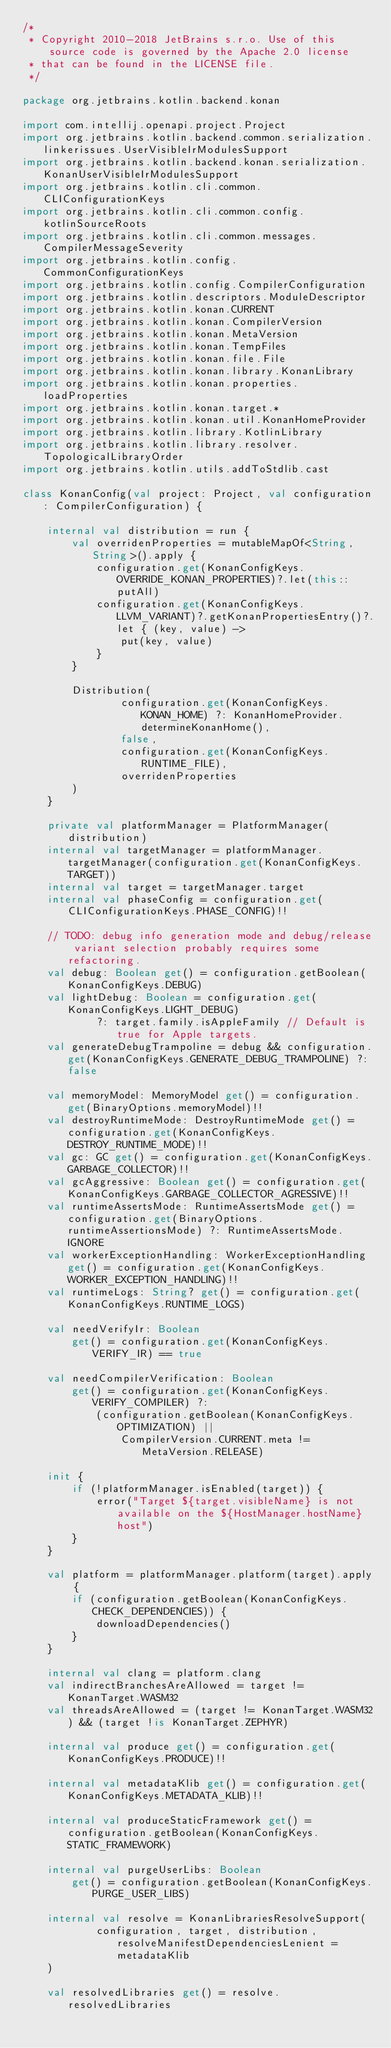Convert code to text. <code><loc_0><loc_0><loc_500><loc_500><_Kotlin_>/*
 * Copyright 2010-2018 JetBrains s.r.o. Use of this source code is governed by the Apache 2.0 license
 * that can be found in the LICENSE file.
 */

package org.jetbrains.kotlin.backend.konan

import com.intellij.openapi.project.Project
import org.jetbrains.kotlin.backend.common.serialization.linkerissues.UserVisibleIrModulesSupport
import org.jetbrains.kotlin.backend.konan.serialization.KonanUserVisibleIrModulesSupport
import org.jetbrains.kotlin.cli.common.CLIConfigurationKeys
import org.jetbrains.kotlin.cli.common.config.kotlinSourceRoots
import org.jetbrains.kotlin.cli.common.messages.CompilerMessageSeverity
import org.jetbrains.kotlin.config.CommonConfigurationKeys
import org.jetbrains.kotlin.config.CompilerConfiguration
import org.jetbrains.kotlin.descriptors.ModuleDescriptor
import org.jetbrains.kotlin.konan.CURRENT
import org.jetbrains.kotlin.konan.CompilerVersion
import org.jetbrains.kotlin.konan.MetaVersion
import org.jetbrains.kotlin.konan.TempFiles
import org.jetbrains.kotlin.konan.file.File
import org.jetbrains.kotlin.konan.library.KonanLibrary
import org.jetbrains.kotlin.konan.properties.loadProperties
import org.jetbrains.kotlin.konan.target.*
import org.jetbrains.kotlin.konan.util.KonanHomeProvider
import org.jetbrains.kotlin.library.KotlinLibrary
import org.jetbrains.kotlin.library.resolver.TopologicalLibraryOrder
import org.jetbrains.kotlin.utils.addToStdlib.cast

class KonanConfig(val project: Project, val configuration: CompilerConfiguration) {

    internal val distribution = run {
        val overridenProperties = mutableMapOf<String, String>().apply {
            configuration.get(KonanConfigKeys.OVERRIDE_KONAN_PROPERTIES)?.let(this::putAll)
            configuration.get(KonanConfigKeys.LLVM_VARIANT)?.getKonanPropertiesEntry()?.let { (key, value) ->
                put(key, value)
            }
        }

        Distribution(
                configuration.get(KonanConfigKeys.KONAN_HOME) ?: KonanHomeProvider.determineKonanHome(),
                false,
                configuration.get(KonanConfigKeys.RUNTIME_FILE),
                overridenProperties
        )
    }

    private val platformManager = PlatformManager(distribution)
    internal val targetManager = platformManager.targetManager(configuration.get(KonanConfigKeys.TARGET))
    internal val target = targetManager.target
    internal val phaseConfig = configuration.get(CLIConfigurationKeys.PHASE_CONFIG)!!

    // TODO: debug info generation mode and debug/release variant selection probably requires some refactoring.
    val debug: Boolean get() = configuration.getBoolean(KonanConfigKeys.DEBUG)
    val lightDebug: Boolean = configuration.get(KonanConfigKeys.LIGHT_DEBUG)
            ?: target.family.isAppleFamily // Default is true for Apple targets.
    val generateDebugTrampoline = debug && configuration.get(KonanConfigKeys.GENERATE_DEBUG_TRAMPOLINE) ?: false

    val memoryModel: MemoryModel get() = configuration.get(BinaryOptions.memoryModel)!!
    val destroyRuntimeMode: DestroyRuntimeMode get() = configuration.get(KonanConfigKeys.DESTROY_RUNTIME_MODE)!!
    val gc: GC get() = configuration.get(KonanConfigKeys.GARBAGE_COLLECTOR)!!
    val gcAggressive: Boolean get() = configuration.get(KonanConfigKeys.GARBAGE_COLLECTOR_AGRESSIVE)!!
    val runtimeAssertsMode: RuntimeAssertsMode get() = configuration.get(BinaryOptions.runtimeAssertionsMode) ?: RuntimeAssertsMode.IGNORE
    val workerExceptionHandling: WorkerExceptionHandling get() = configuration.get(KonanConfigKeys.WORKER_EXCEPTION_HANDLING)!!
    val runtimeLogs: String? get() = configuration.get(KonanConfigKeys.RUNTIME_LOGS)

    val needVerifyIr: Boolean
        get() = configuration.get(KonanConfigKeys.VERIFY_IR) == true

    val needCompilerVerification: Boolean
        get() = configuration.get(KonanConfigKeys.VERIFY_COMPILER) ?:
            (configuration.getBoolean(KonanConfigKeys.OPTIMIZATION) ||
                CompilerVersion.CURRENT.meta != MetaVersion.RELEASE)

    init {
        if (!platformManager.isEnabled(target)) {
            error("Target ${target.visibleName} is not available on the ${HostManager.hostName} host")
        }
    }

    val platform = platformManager.platform(target).apply {
        if (configuration.getBoolean(KonanConfigKeys.CHECK_DEPENDENCIES)) {
            downloadDependencies()
        }
    }

    internal val clang = platform.clang
    val indirectBranchesAreAllowed = target != KonanTarget.WASM32
    val threadsAreAllowed = (target != KonanTarget.WASM32) && (target !is KonanTarget.ZEPHYR)

    internal val produce get() = configuration.get(KonanConfigKeys.PRODUCE)!!

    internal val metadataKlib get() = configuration.get(KonanConfigKeys.METADATA_KLIB)!!

    internal val produceStaticFramework get() = configuration.getBoolean(KonanConfigKeys.STATIC_FRAMEWORK)

    internal val purgeUserLibs: Boolean
        get() = configuration.getBoolean(KonanConfigKeys.PURGE_USER_LIBS)

    internal val resolve = KonanLibrariesResolveSupport(
            configuration, target, distribution, resolveManifestDependenciesLenient = metadataKlib
    )

    val resolvedLibraries get() = resolve.resolvedLibraries
</code> 